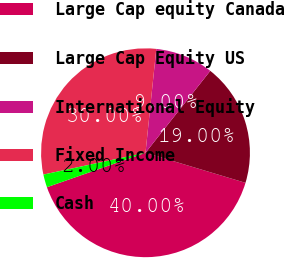<chart> <loc_0><loc_0><loc_500><loc_500><pie_chart><fcel>Large Cap equity Canada<fcel>Large Cap Equity US<fcel>International Equity<fcel>Fixed Income<fcel>Cash<nl><fcel>40.0%<fcel>19.0%<fcel>9.0%<fcel>30.0%<fcel>2.0%<nl></chart> 